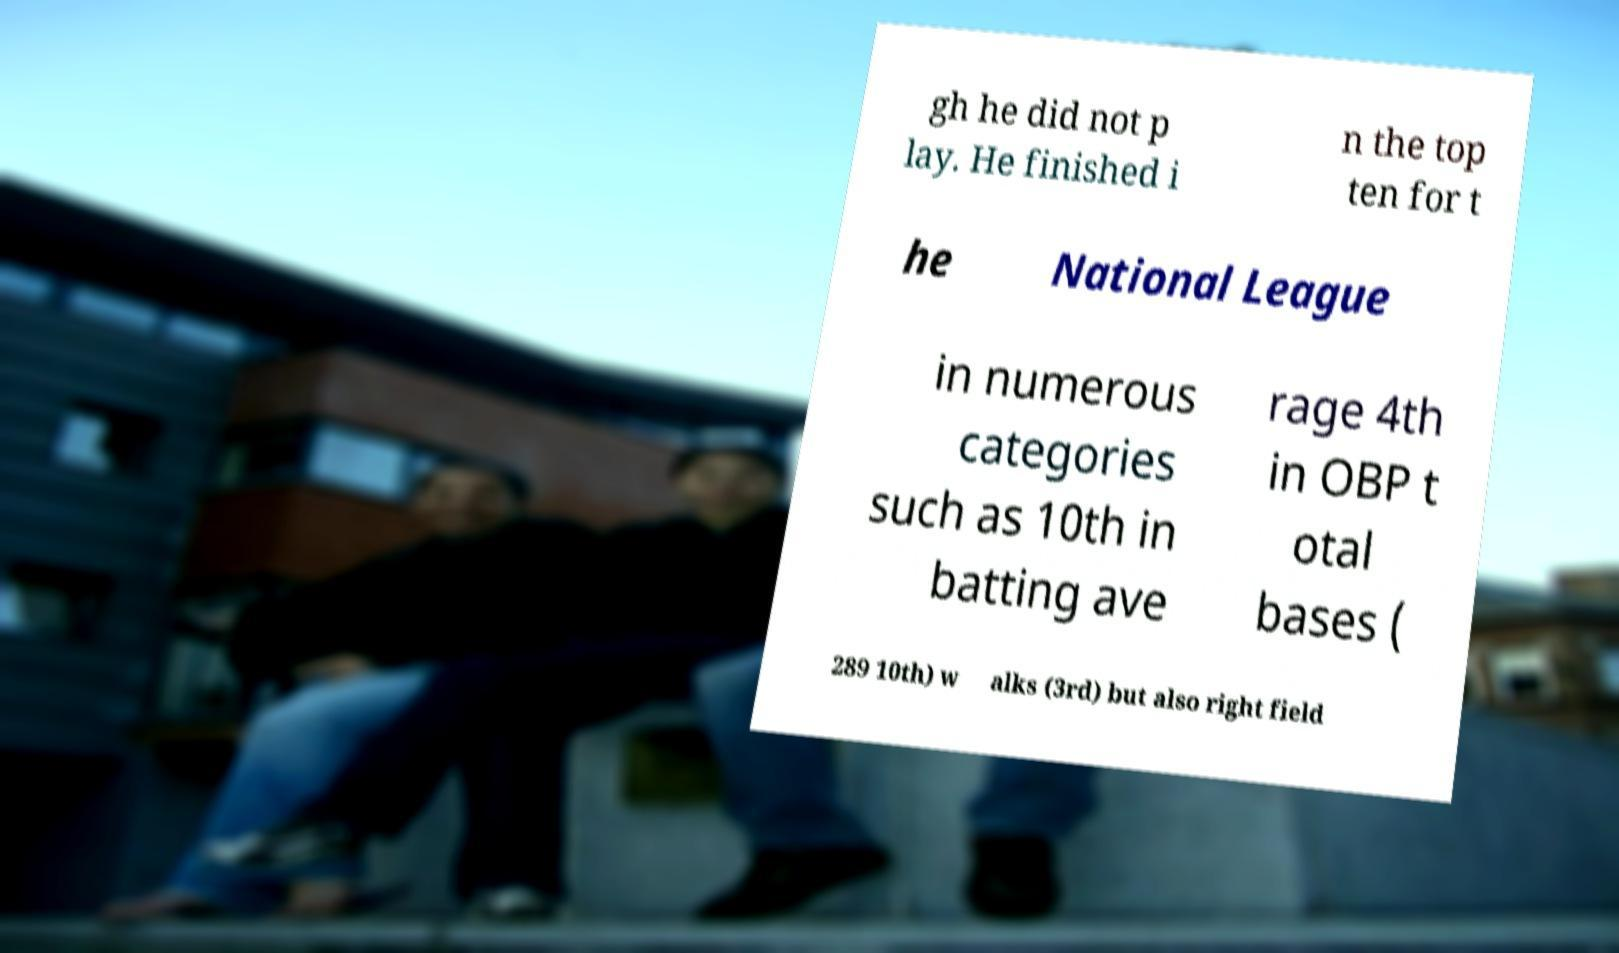Could you assist in decoding the text presented in this image and type it out clearly? gh he did not p lay. He finished i n the top ten for t he National League in numerous categories such as 10th in batting ave rage 4th in OBP t otal bases ( 289 10th) w alks (3rd) but also right field 